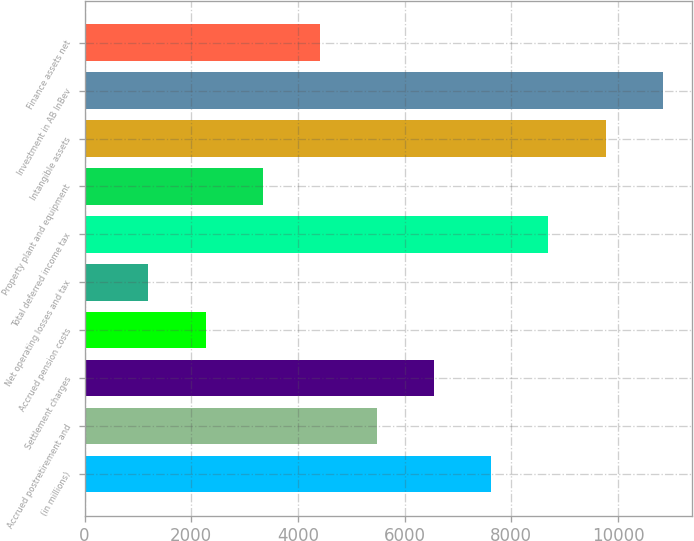Convert chart. <chart><loc_0><loc_0><loc_500><loc_500><bar_chart><fcel>(in millions)<fcel>Accrued postretirement and<fcel>Settlement charges<fcel>Accrued pension costs<fcel>Net operating losses and tax<fcel>Total deferred income tax<fcel>Property plant and equipment<fcel>Intangible assets<fcel>Investment in AB InBev<fcel>Finance assets net<nl><fcel>7625.5<fcel>5482.5<fcel>6554<fcel>2268<fcel>1196.5<fcel>8697<fcel>3339.5<fcel>9768.5<fcel>10840<fcel>4411<nl></chart> 